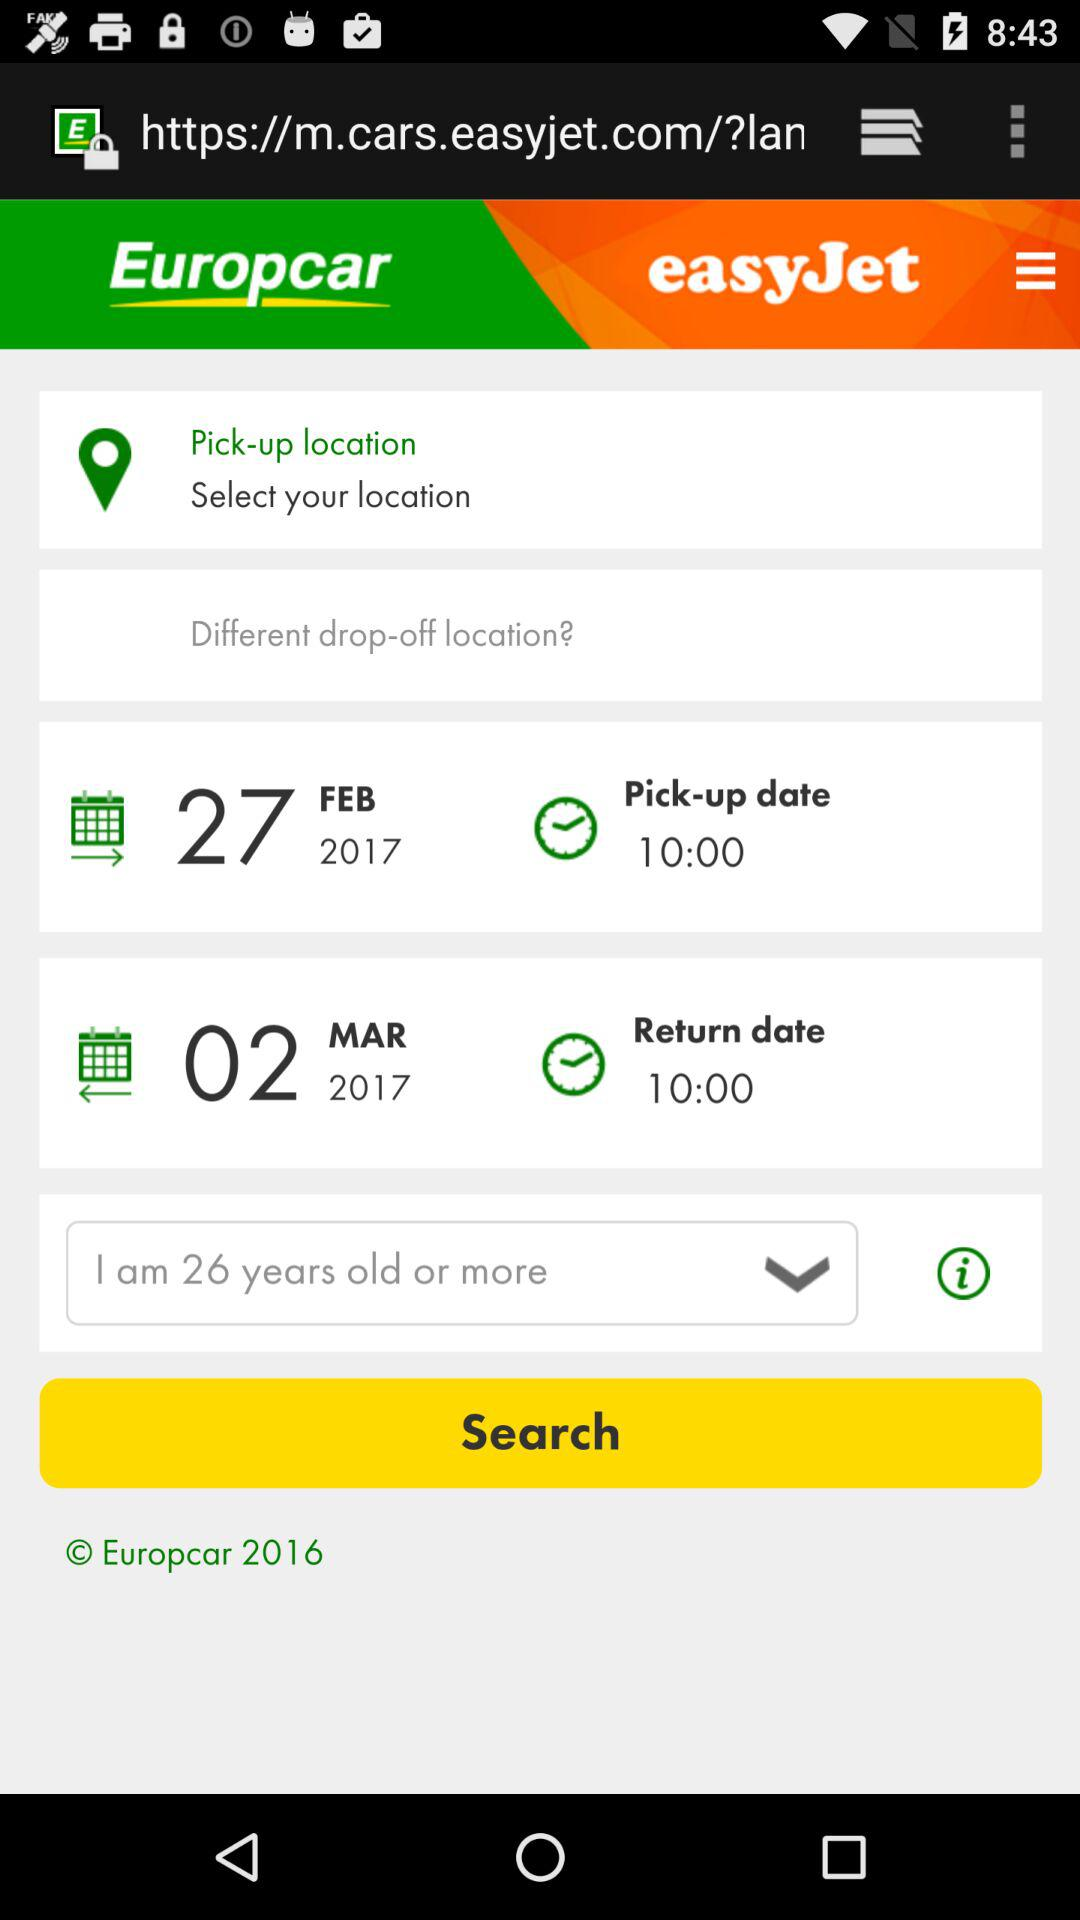What is the scheduled return time? The scheduled return time is 10:00. 